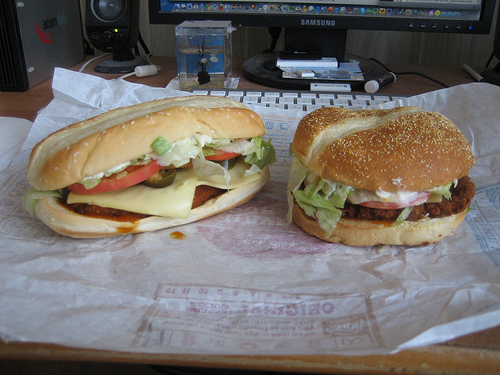Please provide the bounding box coordinate of the region this sentence describes: part of a cloth. Coordinates: [0.48, 0.67, 0.55, 0.79]. This covers a patterned or plain cloth likely placed under or beside the food item. 